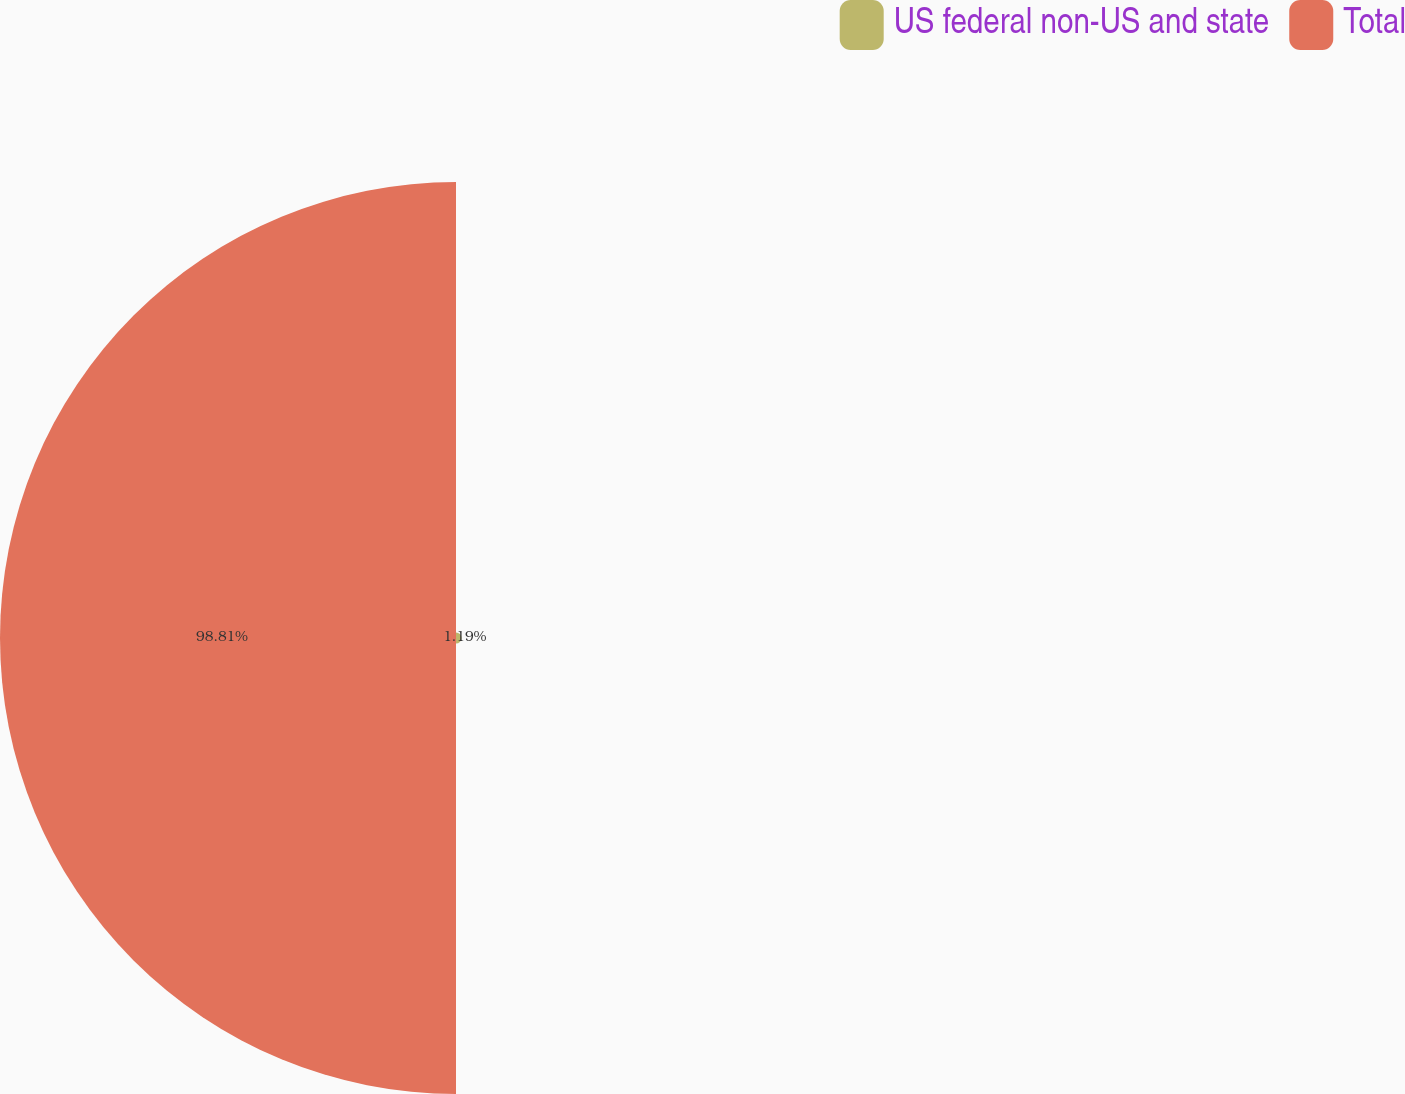<chart> <loc_0><loc_0><loc_500><loc_500><pie_chart><fcel>US federal non-US and state<fcel>Total<nl><fcel>1.19%<fcel>98.81%<nl></chart> 